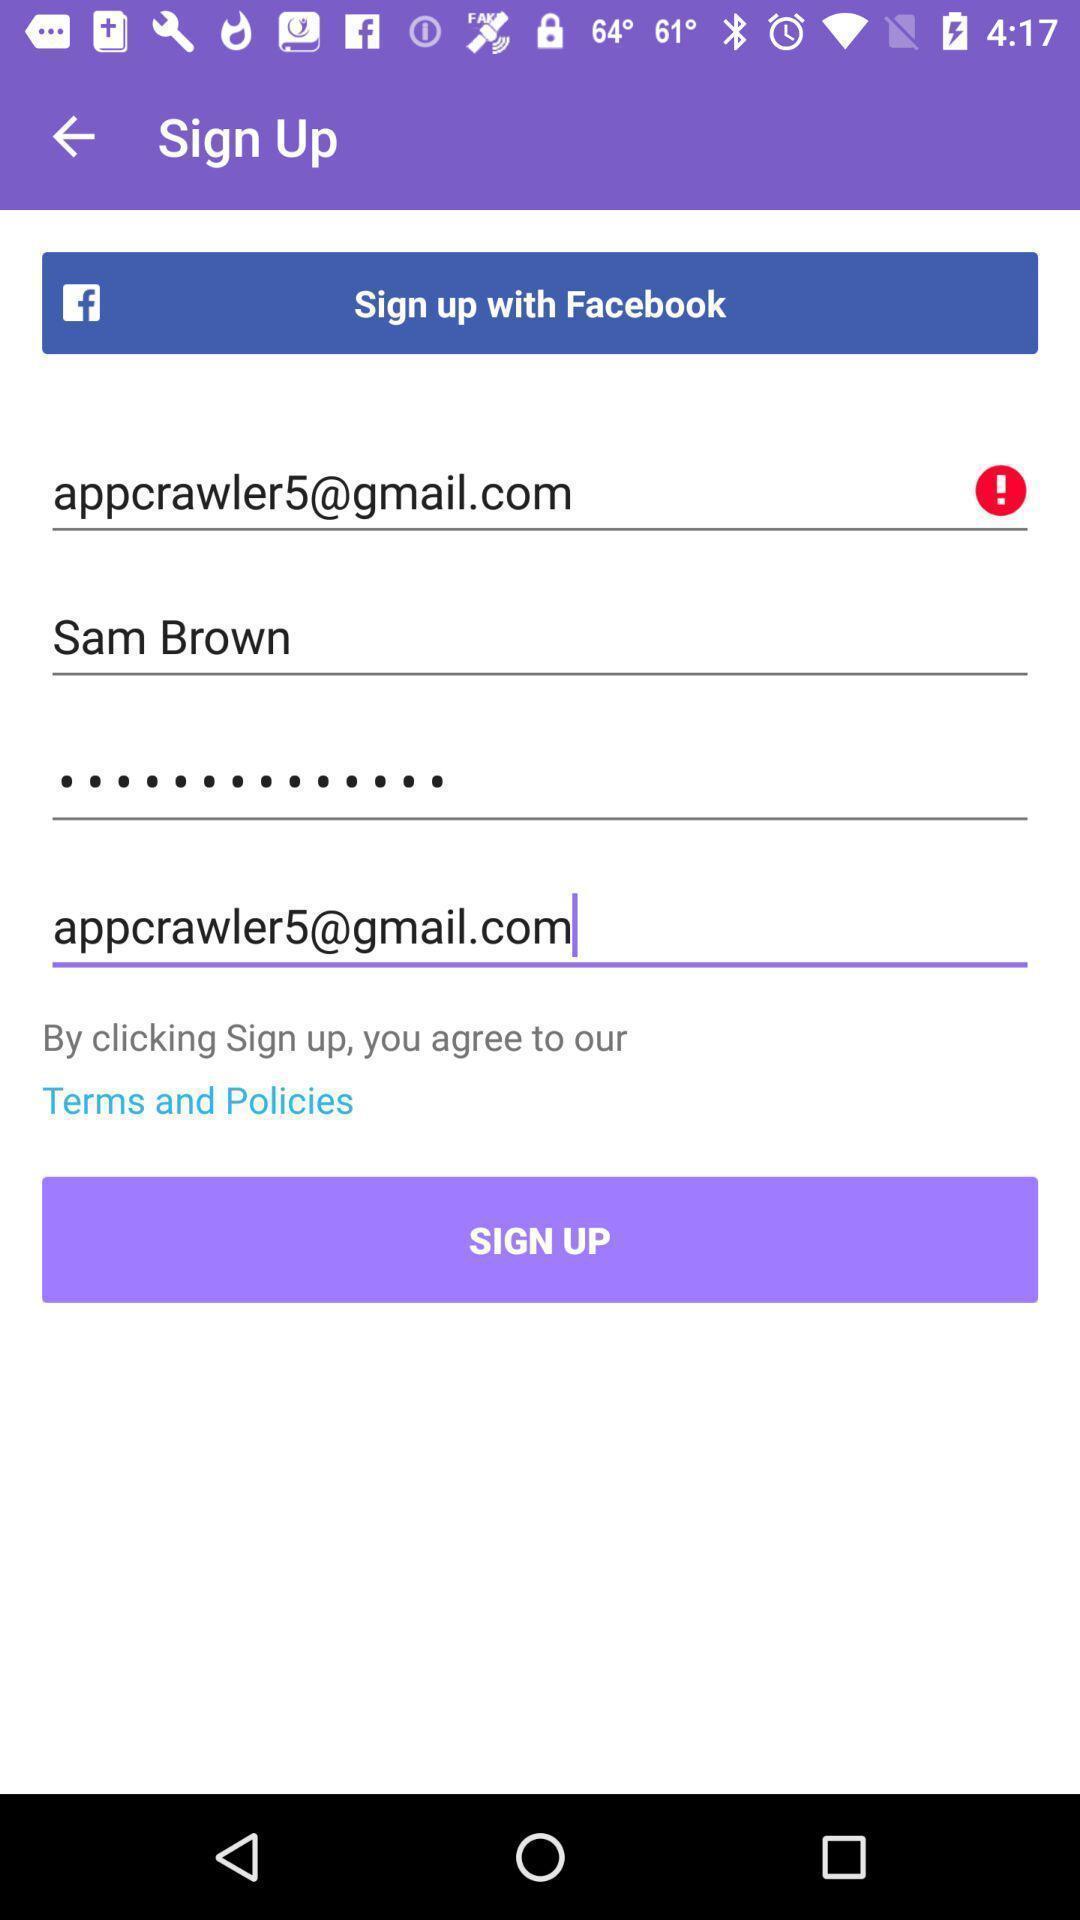Provide a textual representation of this image. Sign up page of a communication application. 